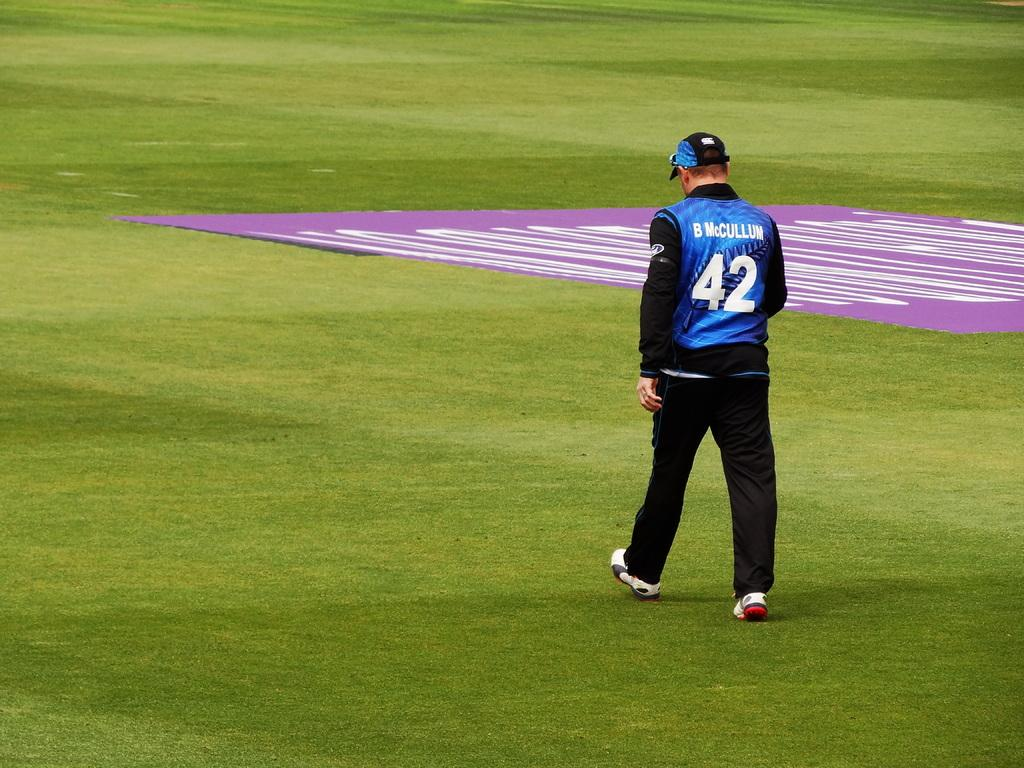Provide a one-sentence caption for the provided image. Number 42, B McCullum walks across a very green field. 